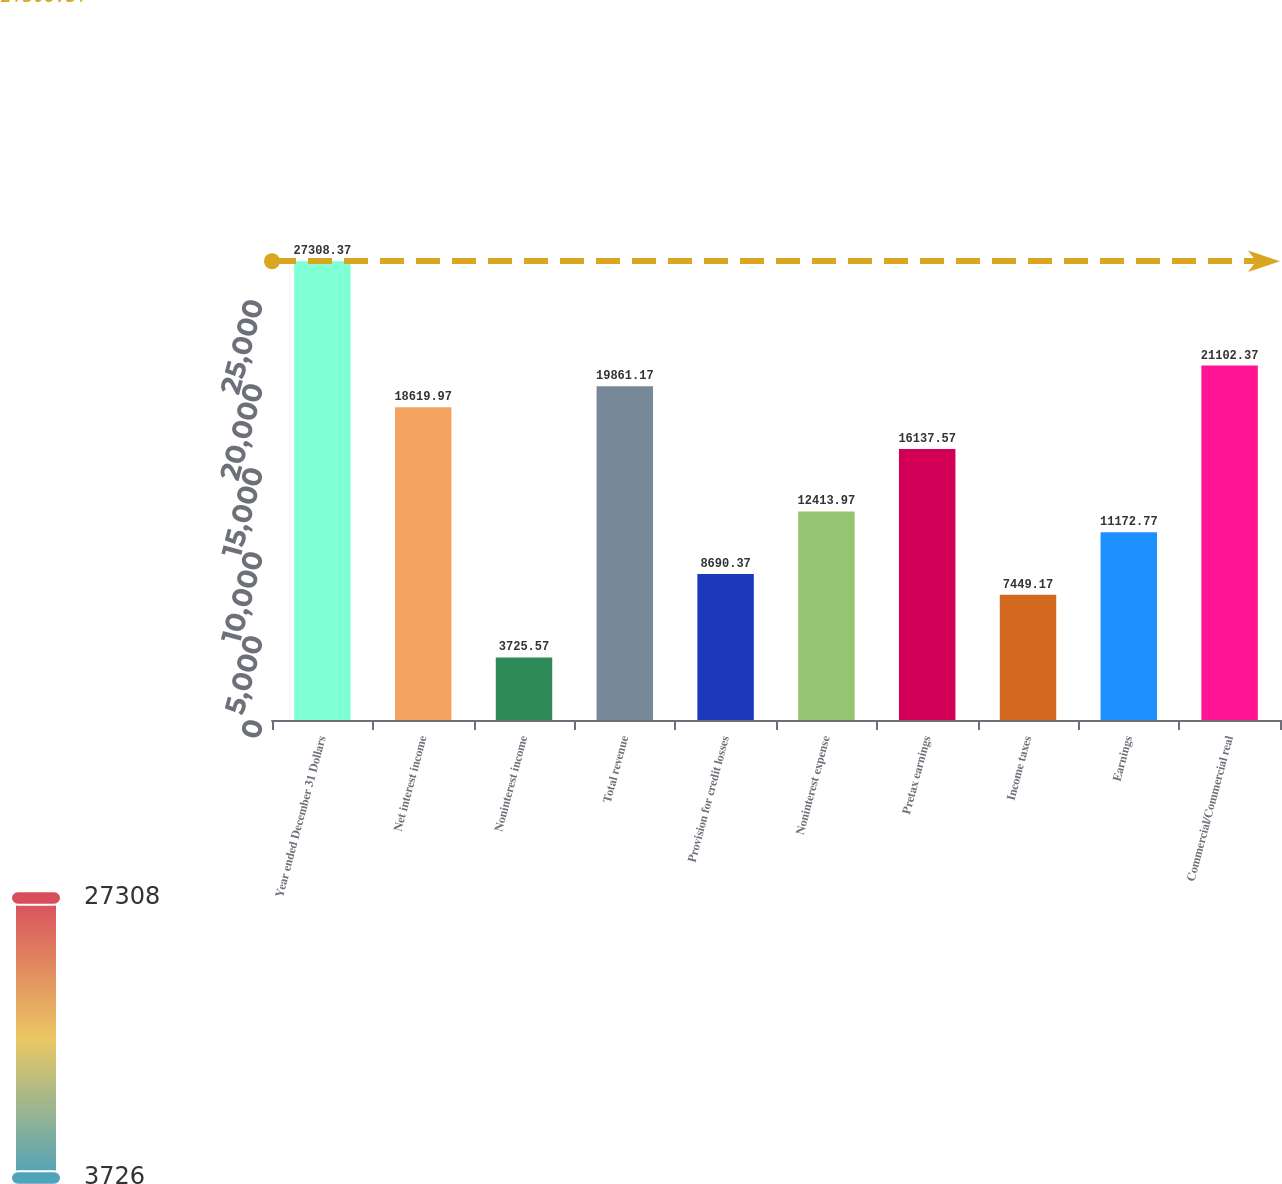Convert chart. <chart><loc_0><loc_0><loc_500><loc_500><bar_chart><fcel>Year ended December 31 Dollars<fcel>Net interest income<fcel>Noninterest income<fcel>Total revenue<fcel>Provision for credit losses<fcel>Noninterest expense<fcel>Pretax earnings<fcel>Income taxes<fcel>Earnings<fcel>Commercial/Commercial real<nl><fcel>27308.4<fcel>18620<fcel>3725.57<fcel>19861.2<fcel>8690.37<fcel>12414<fcel>16137.6<fcel>7449.17<fcel>11172.8<fcel>21102.4<nl></chart> 